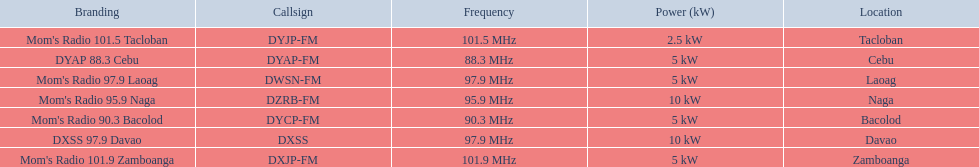What is the difference in kw between naga and bacolod radio? 5 kW. 